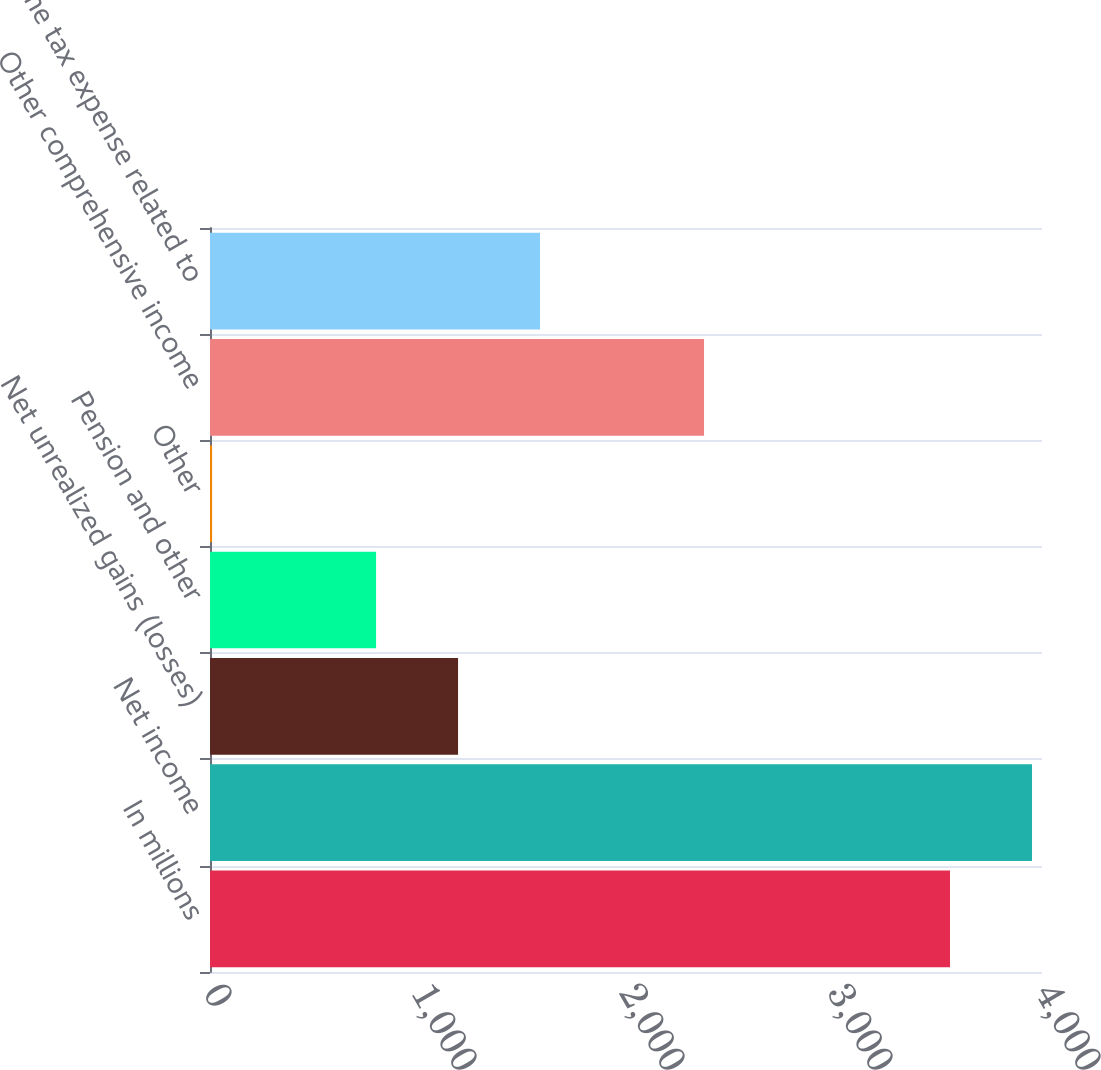<chart> <loc_0><loc_0><loc_500><loc_500><bar_chart><fcel>In millions<fcel>Net income<fcel>Net unrealized gains (losses)<fcel>Pension and other<fcel>Other<fcel>Other comprehensive income<fcel>Income tax expense related to<nl><fcel>3557.8<fcel>3952<fcel>1192.6<fcel>798.4<fcel>10<fcel>2375.2<fcel>1586.8<nl></chart> 